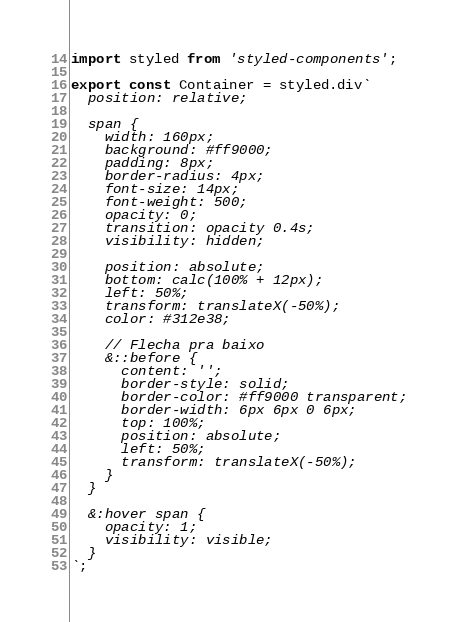<code> <loc_0><loc_0><loc_500><loc_500><_TypeScript_>import styled from 'styled-components';

export const Container = styled.div`
  position: relative;

  span {
    width: 160px;
    background: #ff9000;
    padding: 8px;
    border-radius: 4px;
    font-size: 14px;
    font-weight: 500;
    opacity: 0;
    transition: opacity 0.4s;
    visibility: hidden;

    position: absolute;
    bottom: calc(100% + 12px);
    left: 50%;
    transform: translateX(-50%);
    color: #312e38;

    // Flecha pra baixo
    &::before {
      content: '';
      border-style: solid;
      border-color: #ff9000 transparent;
      border-width: 6px 6px 0 6px;
      top: 100%;
      position: absolute;
      left: 50%;
      transform: translateX(-50%);
    }
  }

  &:hover span {
    opacity: 1;
    visibility: visible;
  }
`;
</code> 